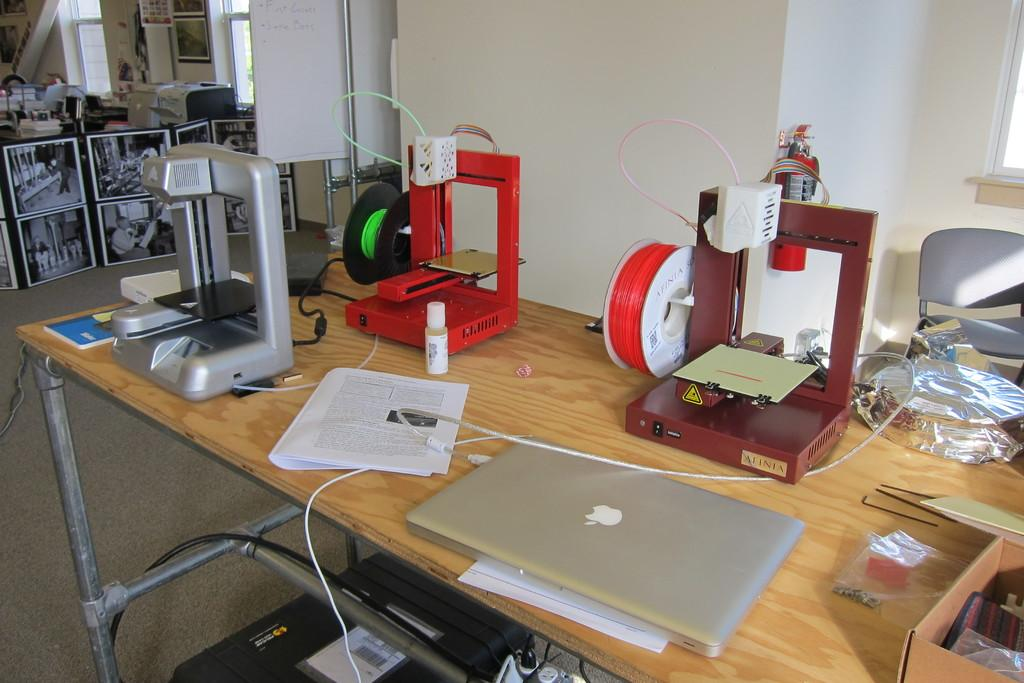What is the main object in the center of the image? There is a table in the center of the image. What is placed on the table? There is a machine on the table, along with other objects such as "tab." What can be seen in the background of the image? There is a wall in the background of the image. What is hung on the wall? There are photo frames on the wall. What type of tin is being used to start the birthday celebration in the image? There is no tin or birthday celebration present in the image. 